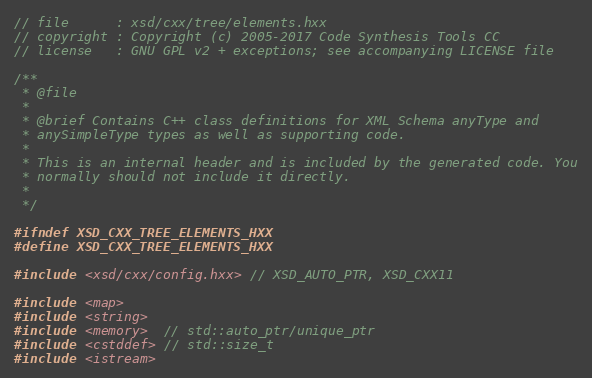Convert code to text. <code><loc_0><loc_0><loc_500><loc_500><_C++_>// file      : xsd/cxx/tree/elements.hxx
// copyright : Copyright (c) 2005-2017 Code Synthesis Tools CC
// license   : GNU GPL v2 + exceptions; see accompanying LICENSE file

/**
 * @file
 *
 * @brief Contains C++ class definitions for XML Schema anyType and
 * anySimpleType types as well as supporting code.
 *
 * This is an internal header and is included by the generated code. You
 * normally should not include it directly.
 *
 */

#ifndef XSD_CXX_TREE_ELEMENTS_HXX
#define XSD_CXX_TREE_ELEMENTS_HXX

#include <xsd/cxx/config.hxx> // XSD_AUTO_PTR, XSD_CXX11

#include <map>
#include <string>
#include <memory>  // std::auto_ptr/unique_ptr
#include <cstddef> // std::size_t
#include <istream></code> 